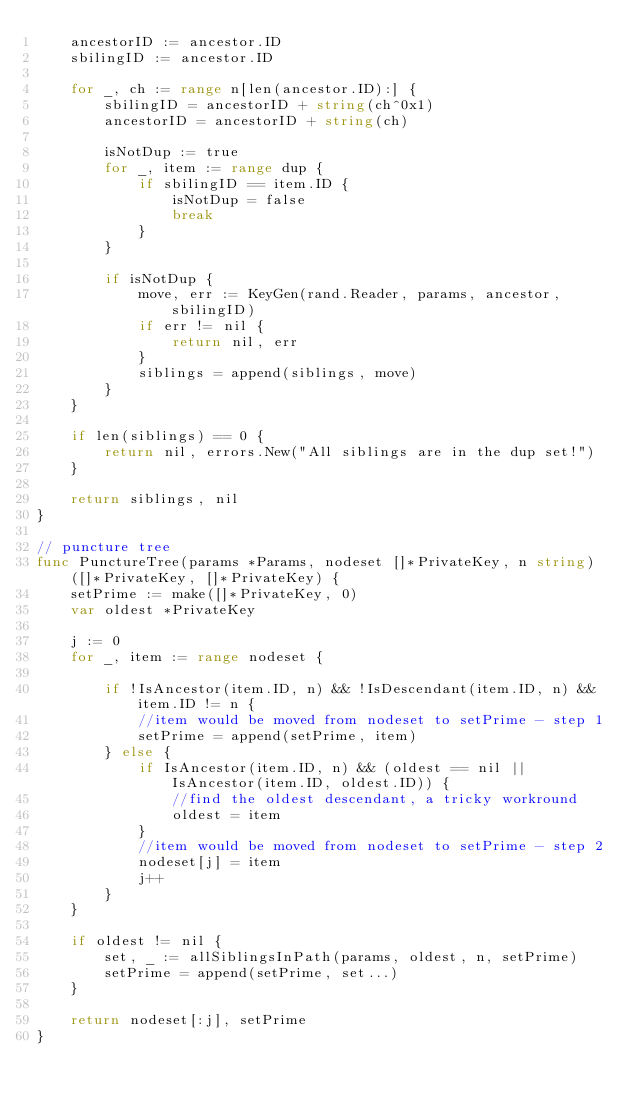Convert code to text. <code><loc_0><loc_0><loc_500><loc_500><_Go_>	ancestorID := ancestor.ID
	sbilingID := ancestor.ID

	for _, ch := range n[len(ancestor.ID):] {
		sbilingID = ancestorID + string(ch^0x1)
		ancestorID = ancestorID + string(ch)

		isNotDup := true
		for _, item := range dup {
			if sbilingID == item.ID {
				isNotDup = false
				break
			}
		}

		if isNotDup {
			move, err := KeyGen(rand.Reader, params, ancestor, sbilingID)
			if err != nil {
				return nil, err
			}
			siblings = append(siblings, move)
		}
	}

	if len(siblings) == 0 {
		return nil, errors.New("All siblings are in the dup set!")
	}

	return siblings, nil
}

// puncture tree
func PunctureTree(params *Params, nodeset []*PrivateKey, n string) ([]*PrivateKey, []*PrivateKey) {
	setPrime := make([]*PrivateKey, 0)
	var oldest *PrivateKey

	j := 0
	for _, item := range nodeset {

		if !IsAncestor(item.ID, n) && !IsDescendant(item.ID, n) && item.ID != n {
			//item would be moved from nodeset to setPrime - step 1
			setPrime = append(setPrime, item)
		} else {
			if IsAncestor(item.ID, n) && (oldest == nil || IsAncestor(item.ID, oldest.ID)) {
				//find the oldest descendant, a tricky workround
				oldest = item
			}
			//item would be moved from nodeset to setPrime - step 2
			nodeset[j] = item
			j++
		}
	}

	if oldest != nil {
		set, _ := allSiblingsInPath(params, oldest, n, setPrime)
		setPrime = append(setPrime, set...)
	}

	return nodeset[:j], setPrime
}
</code> 